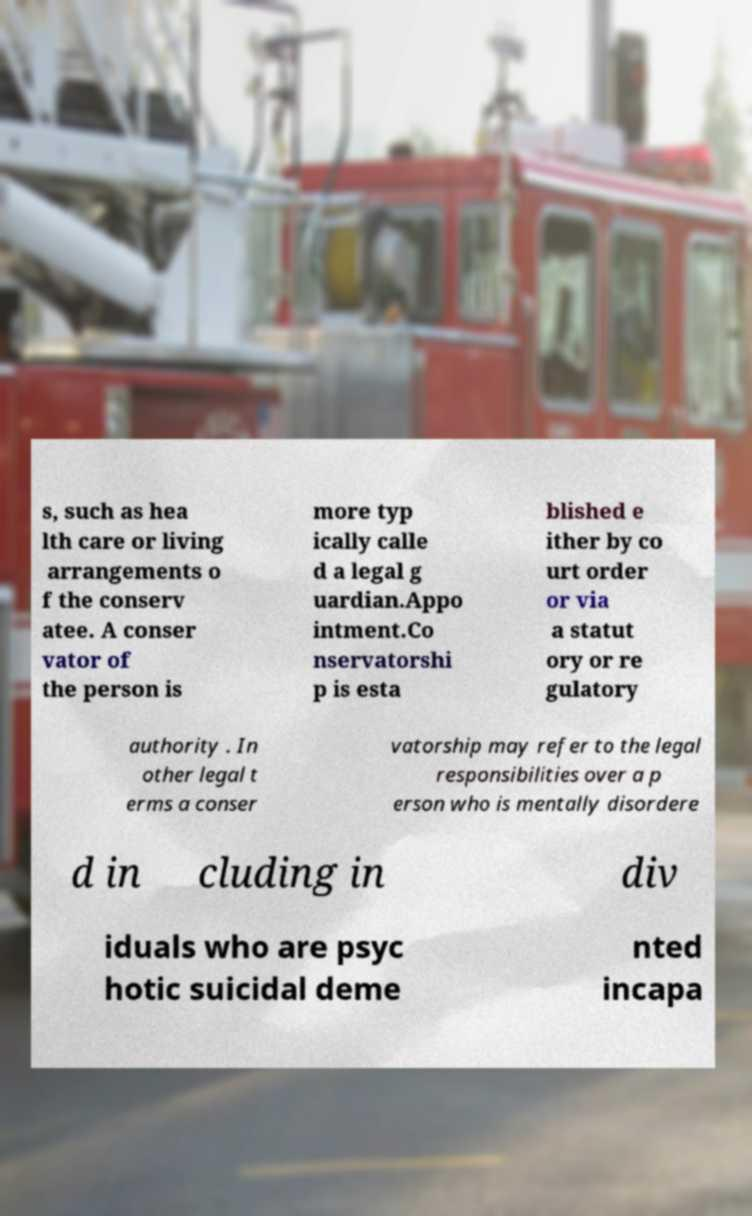Could you extract and type out the text from this image? s, such as hea lth care or living arrangements o f the conserv atee. A conser vator of the person is more typ ically calle d a legal g uardian.Appo intment.Co nservatorshi p is esta blished e ither by co urt order or via a statut ory or re gulatory authority . In other legal t erms a conser vatorship may refer to the legal responsibilities over a p erson who is mentally disordere d in cluding in div iduals who are psyc hotic suicidal deme nted incapa 